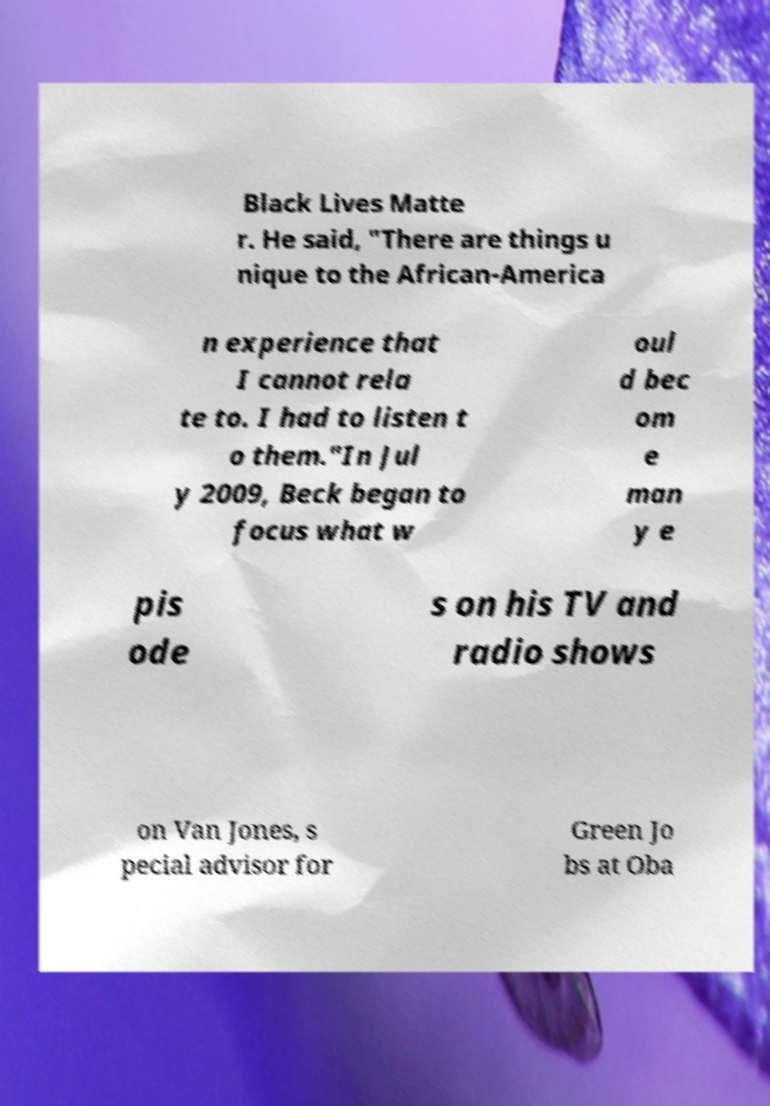For documentation purposes, I need the text within this image transcribed. Could you provide that? Black Lives Matte r. He said, "There are things u nique to the African-America n experience that I cannot rela te to. I had to listen t o them."In Jul y 2009, Beck began to focus what w oul d bec om e man y e pis ode s on his TV and radio shows on Van Jones, s pecial advisor for Green Jo bs at Oba 